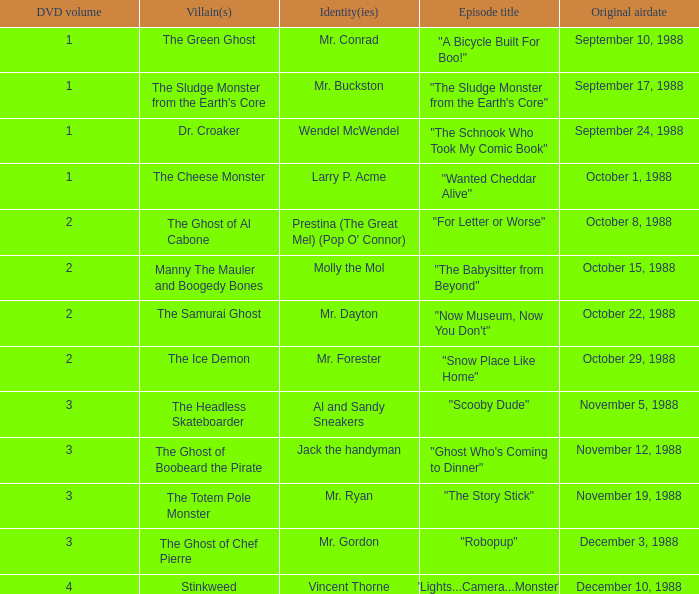Name the original airdate for mr. buckston September 17, 1988. 